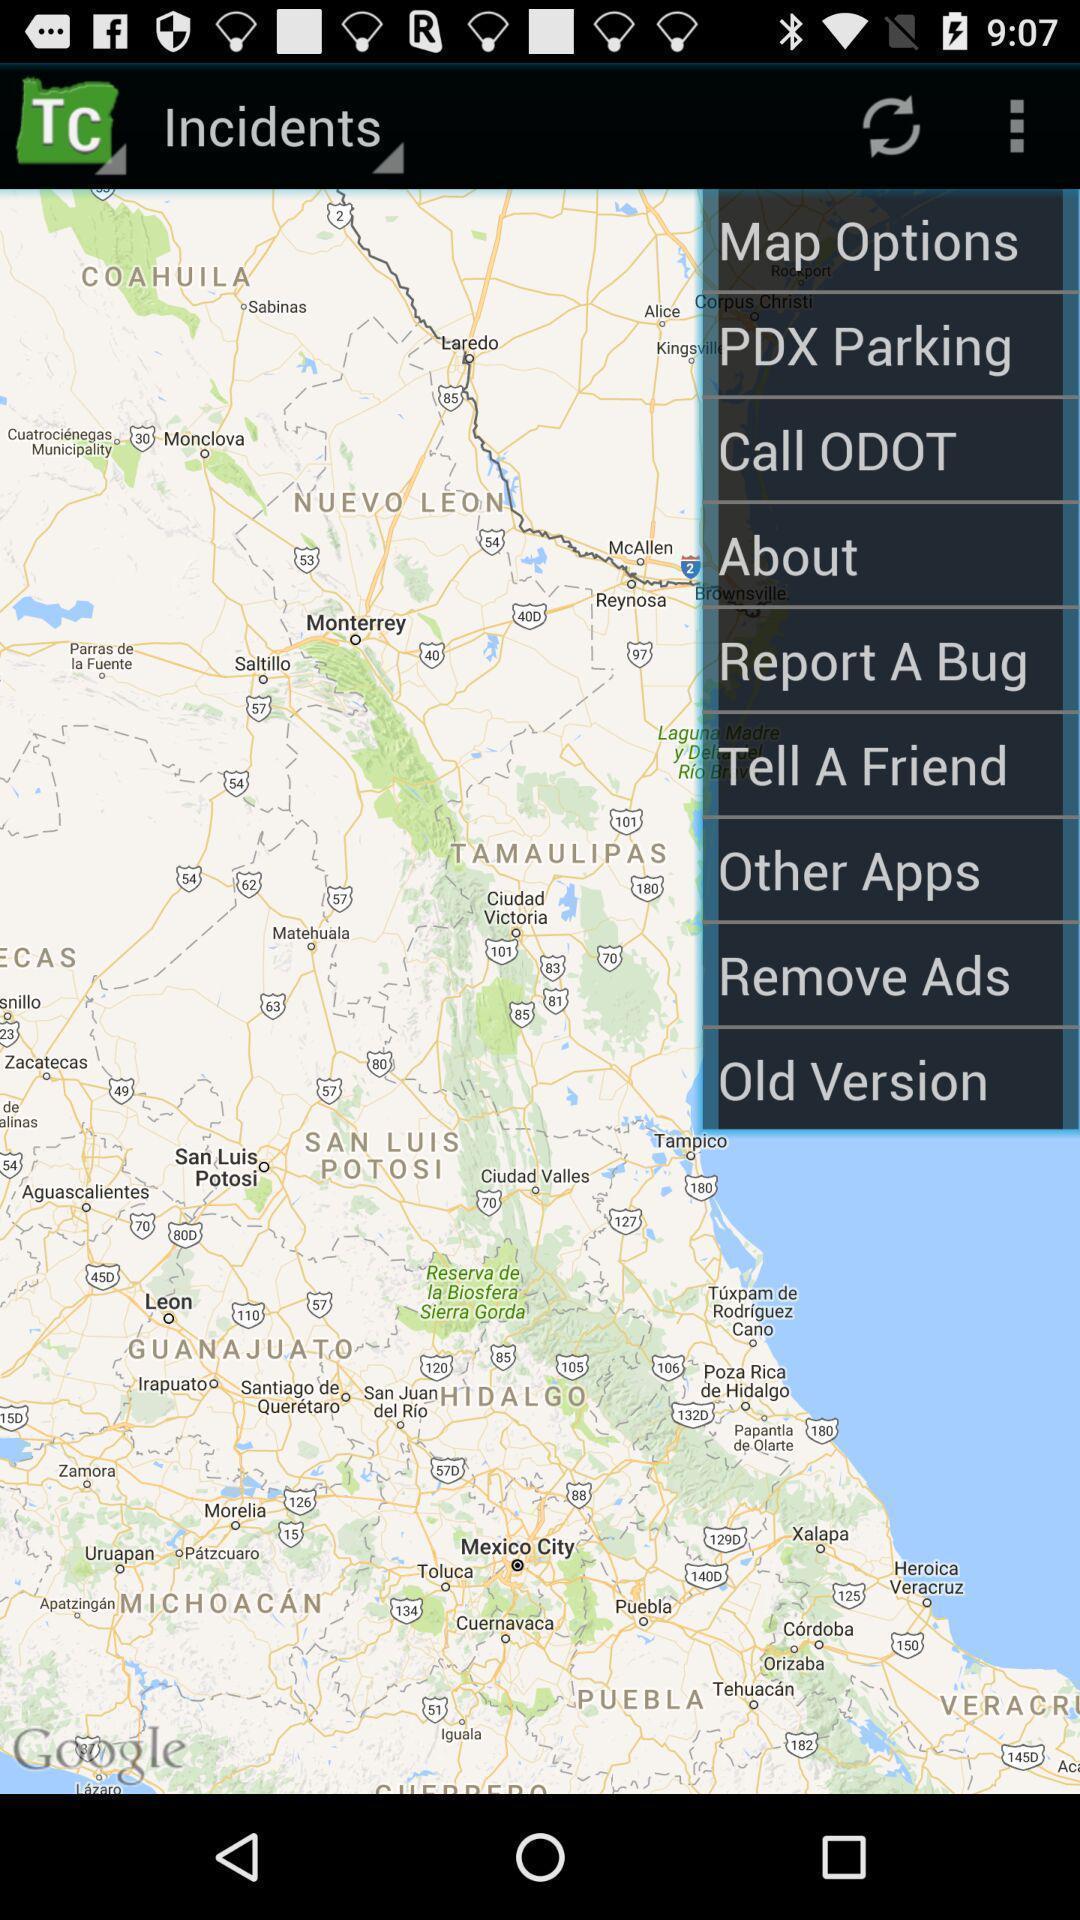Give me a narrative description of this picture. Page showing different options in application. 